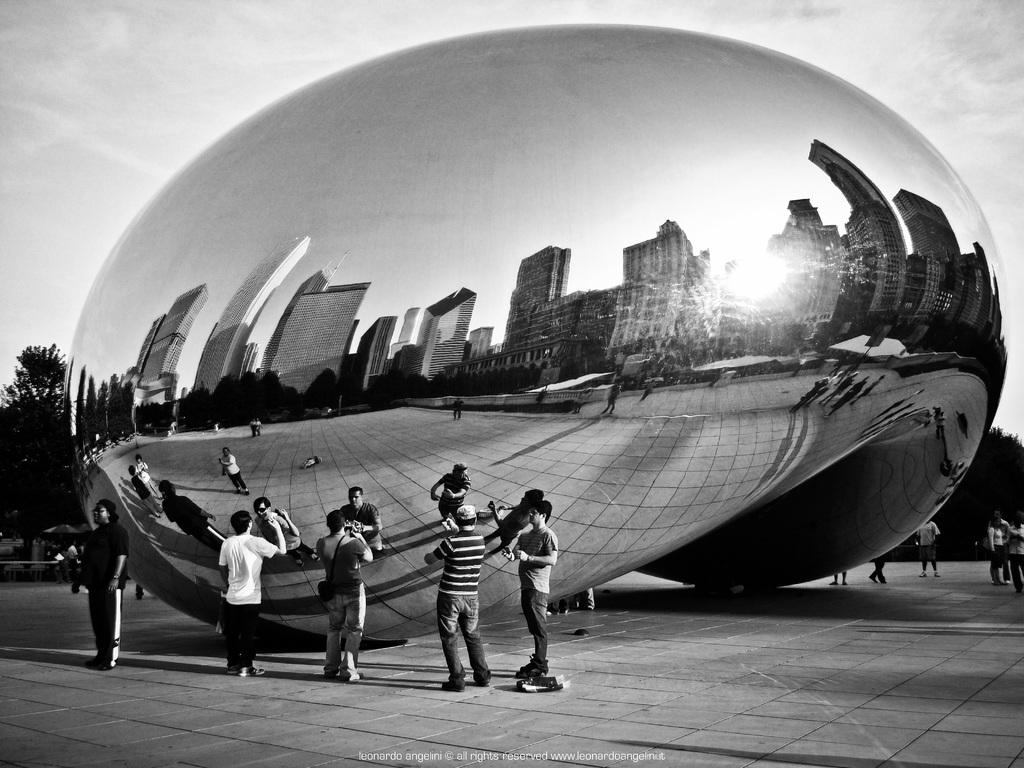What is the color scheme of the image? The image is black and white. What can be seen in the image besides the persons standing on the floor? There is a sculpture, trees, and the sky visible in the image. What is the condition of the sky in the image? The sky is visible in the image, and clouds are present. What type of creature can be seen interacting with the sculpture in the image? There is no creature present in the image, and therefore no such interaction can be observed. What is the tendency of the persons standing on the floor in the image? There is no information about the tendency of the persons in the image, as the provided facts do not mention their actions or emotions. 